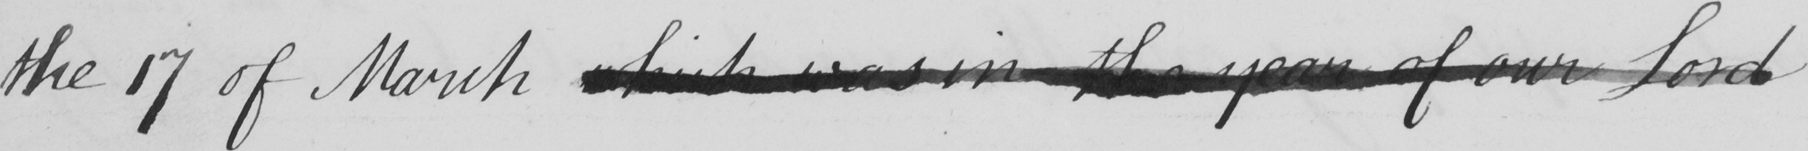Please transcribe the handwritten text in this image. the 17 of March which was in the year of our Lord 